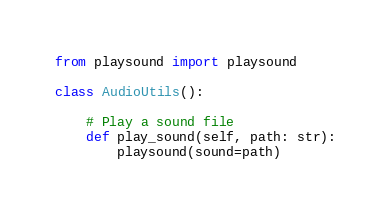<code> <loc_0><loc_0><loc_500><loc_500><_Python_>from playsound import playsound

class AudioUtils():
    
    # Play a sound file
    def play_sound(self, path: str):
        playsound(sound=path)</code> 